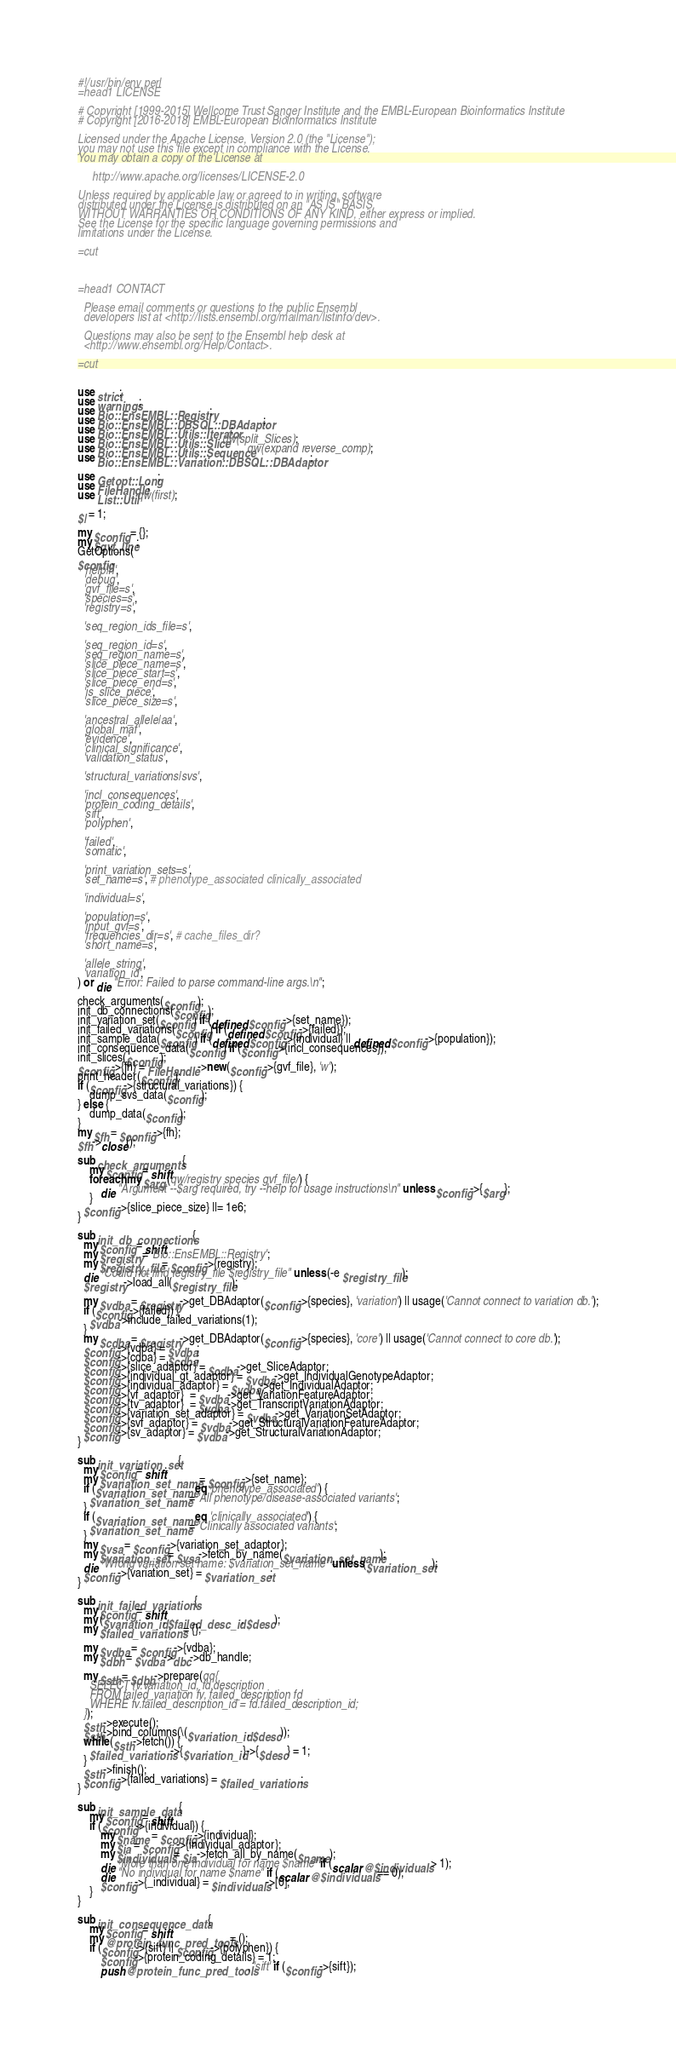<code> <loc_0><loc_0><loc_500><loc_500><_Perl_>#!/usr/bin/env perl
=head1 LICENSE

# Copyright [1999-2015] Wellcome Trust Sanger Institute and the EMBL-European Bioinformatics Institute
# Copyright [2016-2018] EMBL-European Bioinformatics Institute

Licensed under the Apache License, Version 2.0 (the "License");
you may not use this file except in compliance with the License.
You may obtain a copy of the License at

     http://www.apache.org/licenses/LICENSE-2.0

Unless required by applicable law or agreed to in writing, software
distributed under the License is distributed on an "AS IS" BASIS,
WITHOUT WARRANTIES OR CONDITIONS OF ANY KIND, either express or implied.
See the License for the specific language governing permissions and
limitations under the License.

=cut



=head1 CONTACT

  Please email comments or questions to the public Ensembl
  developers list at <http://lists.ensembl.org/mailman/listinfo/dev>.

  Questions may also be sent to the Ensembl help desk at
  <http://www.ensembl.org/Help/Contact>.

=cut


use strict;
use warnings;
use Bio::EnsEMBL::Registry;
use Bio::EnsEMBL::DBSQL::DBAdaptor;
use Bio::EnsEMBL::Utils::Iterator;
use Bio::EnsEMBL::Utils::Slice qw(split_Slices);
use Bio::EnsEMBL::Utils::Sequence qw(expand reverse_comp);
use Bio::EnsEMBL::Variation::DBSQL::DBAdaptor;

use Getopt::Long;
use FileHandle; 
use List::Util qw(first);

$| = 1;

my $config = {};
my $gvf_line;
GetOptions(
$config,
  'help|h',
  'debug',
  'gvf_file=s',
  'species=s',
  'registry=s',

  'seq_region_ids_file=s',

  'seq_region_id=s',
  'seq_region_name=s',
  'slice_piece_name=s',
  'slice_piece_start=s',
  'slice_piece_end=s',
  'is_slice_piece',
  'slice_piece_size=s',

  'ancestral_allele|aa',
  'global_maf',
  'evidence',
  'clinical_significance',	
  'validation_status',

  'structural_variations|svs',

  'incl_consequences',
  'protein_coding_details',
  'sift',
  'polyphen',

  'failed',
  'somatic',

  'print_variation_sets=s', 
  'set_name=s', # phenotype_associated clinically_associated

  'individual=s',

  'population=s',
  'input_gvf=s',
  'frequencies_dir=s', # cache_files_dir?
  'short_name=s',

  'allele_string',
  'variation_id',
) or die "Error: Failed to parse command-line args.\n";

check_arguments($config);
init_db_connections($config);
init_variation_set($config) if (defined $config->{set_name});
init_failed_variations($config) if (defined $config->{failed});
init_sample_data($config) if (defined $config->{individual} || defined $config->{population});
init_consequence_data($config) if ($config->{incl_consequences});
init_slices($config);
$config->{fh} = FileHandle->new($config->{gvf_file}, 'w');
print_header($config);
if ($config->{structural_variations}) {
    dump_svs_data($config);
} else {
    dump_data($config);
}
my $fh = $config->{fh};
$fh->close();

sub check_arguments {
    my $config = shift;
    foreach my $arg (qw/registry species gvf_file/) {
        die "Argument --$arg required, try --help for usage instructions\n" unless $config->{$arg};
    } 
  $config->{slice_piece_size} ||= 1e6;
}

sub init_db_connections {
  my $config = shift;
  my $registry = 'Bio::EnsEMBL::Registry';
  my $registry_file = $config->{registry};
  die "Could not find registry_file $registry_file" unless (-e $registry_file);
  $registry->load_all($registry_file);

  my $vdba = $registry->get_DBAdaptor($config->{species}, 'variation') || usage('Cannot connect to variation db.');
  if ($config->{failed}) {
    $vdba->include_failed_variations(1);
  }
  my $cdba = $registry->get_DBAdaptor($config->{species}, 'core') || usage('Cannot connect to core db.');
  $config->{vdba} = $vdba;
  $config->{cdba} = $cdba;
  $config->{slice_adaptor} = $cdba->get_SliceAdaptor;
  $config->{individual_gt_adaptor} = $vdba->get_IndividualGenotypeAdaptor;
  $config->{individual_adaptor} = $vdba->get_IndividualAdaptor;
  $config->{vf_adaptor}  = $vdba->get_VariationFeatureAdaptor;
  $config->{tv_adaptor}  = $vdba->get_TranscriptVariationAdaptor;
  $config->{variation_set_adaptor} = $vdba->get_VariationSetAdaptor;
  $config->{svf_adaptor} = $vdba->get_StructuralVariationFeatureAdaptor;
  $config->{sv_adaptor} = $vdba->get_StructuralVariationAdaptor;
}

sub init_variation_set {
  my $config = shift;
  my $variation_set_name = $config->{set_name};
  if ($variation_set_name eq 'phenotype_associated') {
    $variation_set_name = 'All phenotype/disease-associated variants';
  }
  if ($variation_set_name eq 'clinically_associated') {
    $variation_set_name = 'Clinically associated variants';
  }
  my $vsa = $config->{variation_set_adaptor};
  my $variation_set = $vsa->fetch_by_name($variation_set_name);
  die "Wrong variation set name: $variation_set_name" unless($variation_set);
  $config->{variation_set} = $variation_set;
}

sub init_failed_variations {
  my $config = shift;
  my ($variation_id, $failed_desc_id, $desc);
  my $failed_variations = {};

  my $vdba = $config->{vdba};
  my $dbh = $vdba->dbc->db_handle;

  my $sth = $dbh->prepare(qq{
    SELECT fv.variation_id, fd.description
    FROM failed_variation fv, failed_description fd
    WHERE fv.failed_description_id = fd.failed_description_id;
  });
  $sth->execute();
  $sth->bind_columns(\($variation_id, $desc));
  while ($sth->fetch()) {
    $failed_variations->{$variation_id}->{$desc} = 1;
  }
  $sth->finish();
  $config->{failed_variations} = $failed_variations;
}

sub init_sample_data {
    my $config = shift;
    if ($config->{individual}) {
        my $name = $config->{individual};
        my $ia = $config->{individual_adaptor};
        my $individuals = $ia->fetch_all_by_name($name);
        die "More than one individual for name $name" if (scalar @$individuals > 1);
        die "No individual for name $name" if (scalar @$individuals == 0);
        $config->{_individual} = $individuals->[0];
    }
}

sub init_consequence_data {
    my $config = shift;
    my @protein_func_pred_tools = ();
    if ($config->{sift} || $config->{polyphen}) {
        $config->{protein_coding_details} = 1;
        push @protein_func_pred_tools, 'sift' if ($config->{sift});</code> 